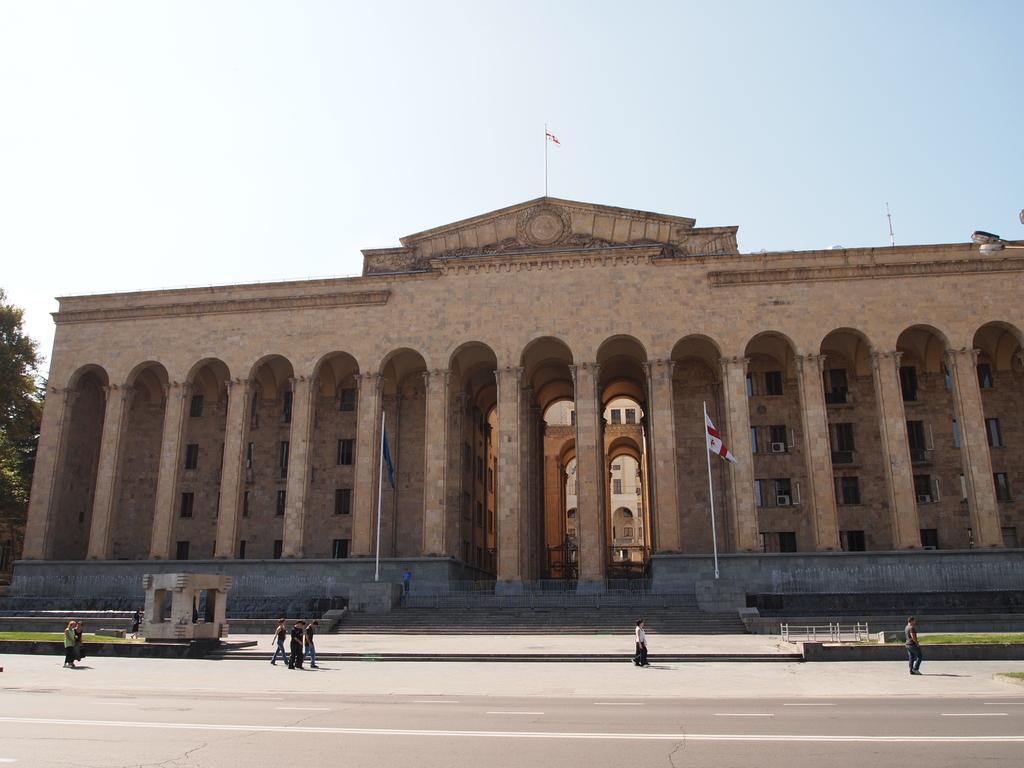What is happening on the road in the image? There are people on the road in the image. What can be seen on the left side of the image? There is a tree on the left side of the image. What is visible in the background of the image? There is a building in the background of the image. What is located at the top of the image? The flag and the sky are visible at the top of the image. Can you tell me how many goats are grazing near the tree in the image? There are no goats present in the image; it features people on the road, a tree on the left side, a building in the background, and a flag and sky at the top. What invention is being used by the people on the road in the image? The provided facts do not mention any specific inventions being used by the people on the road in the image. 